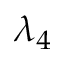<formula> <loc_0><loc_0><loc_500><loc_500>\lambda _ { 4 }</formula> 